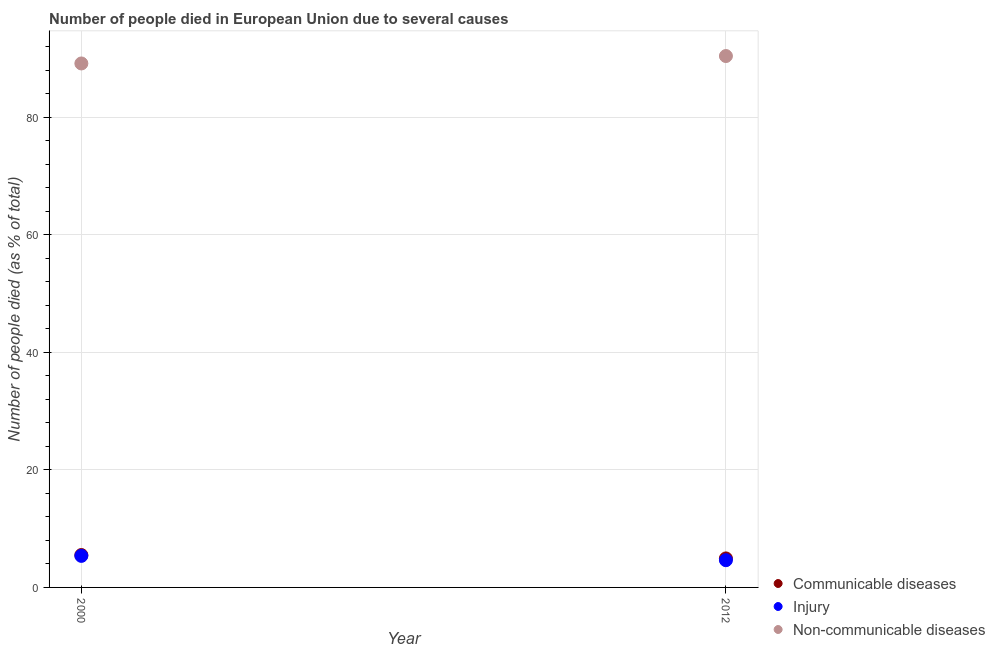How many different coloured dotlines are there?
Your answer should be very brief. 3. Is the number of dotlines equal to the number of legend labels?
Keep it short and to the point. Yes. What is the number of people who died of communicable diseases in 2012?
Your response must be concise. 4.93. Across all years, what is the maximum number of people who died of injury?
Give a very brief answer. 5.37. Across all years, what is the minimum number of people who died of communicable diseases?
Make the answer very short. 4.93. In which year was the number of people who died of injury minimum?
Ensure brevity in your answer.  2012. What is the total number of people who died of communicable diseases in the graph?
Give a very brief answer. 10.44. What is the difference between the number of people who dies of non-communicable diseases in 2000 and that in 2012?
Provide a short and direct response. -1.26. What is the difference between the number of people who dies of non-communicable diseases in 2012 and the number of people who died of communicable diseases in 2000?
Offer a terse response. 84.89. What is the average number of people who dies of non-communicable diseases per year?
Your response must be concise. 89.77. In the year 2000, what is the difference between the number of people who died of injury and number of people who died of communicable diseases?
Make the answer very short. -0.14. In how many years, is the number of people who died of communicable diseases greater than 36 %?
Ensure brevity in your answer.  0. What is the ratio of the number of people who dies of non-communicable diseases in 2000 to that in 2012?
Your response must be concise. 0.99. Is the number of people who died of injury in 2000 less than that in 2012?
Offer a very short reply. No. Is it the case that in every year, the sum of the number of people who died of communicable diseases and number of people who died of injury is greater than the number of people who dies of non-communicable diseases?
Keep it short and to the point. No. Does the number of people who dies of non-communicable diseases monotonically increase over the years?
Make the answer very short. Yes. Is the number of people who dies of non-communicable diseases strictly less than the number of people who died of communicable diseases over the years?
Your answer should be very brief. No. How many dotlines are there?
Ensure brevity in your answer.  3. What is the difference between two consecutive major ticks on the Y-axis?
Your answer should be compact. 20. Does the graph contain grids?
Provide a short and direct response. Yes. What is the title of the graph?
Offer a very short reply. Number of people died in European Union due to several causes. What is the label or title of the X-axis?
Give a very brief answer. Year. What is the label or title of the Y-axis?
Offer a very short reply. Number of people died (as % of total). What is the Number of people died (as % of total) in Communicable diseases in 2000?
Provide a short and direct response. 5.51. What is the Number of people died (as % of total) in Injury in 2000?
Make the answer very short. 5.37. What is the Number of people died (as % of total) of Non-communicable diseases in 2000?
Provide a short and direct response. 89.14. What is the Number of people died (as % of total) in Communicable diseases in 2012?
Give a very brief answer. 4.93. What is the Number of people died (as % of total) in Injury in 2012?
Keep it short and to the point. 4.63. What is the Number of people died (as % of total) of Non-communicable diseases in 2012?
Make the answer very short. 90.4. Across all years, what is the maximum Number of people died (as % of total) in Communicable diseases?
Your response must be concise. 5.51. Across all years, what is the maximum Number of people died (as % of total) in Injury?
Your response must be concise. 5.37. Across all years, what is the maximum Number of people died (as % of total) in Non-communicable diseases?
Your answer should be compact. 90.4. Across all years, what is the minimum Number of people died (as % of total) of Communicable diseases?
Offer a terse response. 4.93. Across all years, what is the minimum Number of people died (as % of total) of Injury?
Offer a very short reply. 4.63. Across all years, what is the minimum Number of people died (as % of total) of Non-communicable diseases?
Provide a succinct answer. 89.14. What is the total Number of people died (as % of total) in Communicable diseases in the graph?
Make the answer very short. 10.44. What is the total Number of people died (as % of total) in Injury in the graph?
Make the answer very short. 10. What is the total Number of people died (as % of total) in Non-communicable diseases in the graph?
Keep it short and to the point. 179.54. What is the difference between the Number of people died (as % of total) of Communicable diseases in 2000 and that in 2012?
Offer a terse response. 0.57. What is the difference between the Number of people died (as % of total) in Injury in 2000 and that in 2012?
Make the answer very short. 0.74. What is the difference between the Number of people died (as % of total) of Non-communicable diseases in 2000 and that in 2012?
Provide a short and direct response. -1.26. What is the difference between the Number of people died (as % of total) of Communicable diseases in 2000 and the Number of people died (as % of total) of Injury in 2012?
Your answer should be compact. 0.88. What is the difference between the Number of people died (as % of total) of Communicable diseases in 2000 and the Number of people died (as % of total) of Non-communicable diseases in 2012?
Your response must be concise. -84.89. What is the difference between the Number of people died (as % of total) of Injury in 2000 and the Number of people died (as % of total) of Non-communicable diseases in 2012?
Make the answer very short. -85.03. What is the average Number of people died (as % of total) in Communicable diseases per year?
Ensure brevity in your answer.  5.22. What is the average Number of people died (as % of total) of Injury per year?
Keep it short and to the point. 5. What is the average Number of people died (as % of total) in Non-communicable diseases per year?
Make the answer very short. 89.77. In the year 2000, what is the difference between the Number of people died (as % of total) in Communicable diseases and Number of people died (as % of total) in Injury?
Provide a short and direct response. 0.14. In the year 2000, what is the difference between the Number of people died (as % of total) in Communicable diseases and Number of people died (as % of total) in Non-communicable diseases?
Keep it short and to the point. -83.63. In the year 2000, what is the difference between the Number of people died (as % of total) of Injury and Number of people died (as % of total) of Non-communicable diseases?
Your response must be concise. -83.77. In the year 2012, what is the difference between the Number of people died (as % of total) of Communicable diseases and Number of people died (as % of total) of Injury?
Make the answer very short. 0.3. In the year 2012, what is the difference between the Number of people died (as % of total) of Communicable diseases and Number of people died (as % of total) of Non-communicable diseases?
Offer a very short reply. -85.47. In the year 2012, what is the difference between the Number of people died (as % of total) of Injury and Number of people died (as % of total) of Non-communicable diseases?
Provide a short and direct response. -85.77. What is the ratio of the Number of people died (as % of total) in Communicable diseases in 2000 to that in 2012?
Offer a very short reply. 1.12. What is the ratio of the Number of people died (as % of total) of Injury in 2000 to that in 2012?
Your response must be concise. 1.16. What is the ratio of the Number of people died (as % of total) of Non-communicable diseases in 2000 to that in 2012?
Give a very brief answer. 0.99. What is the difference between the highest and the second highest Number of people died (as % of total) of Communicable diseases?
Your response must be concise. 0.57. What is the difference between the highest and the second highest Number of people died (as % of total) in Injury?
Ensure brevity in your answer.  0.74. What is the difference between the highest and the second highest Number of people died (as % of total) of Non-communicable diseases?
Offer a terse response. 1.26. What is the difference between the highest and the lowest Number of people died (as % of total) in Communicable diseases?
Your answer should be compact. 0.57. What is the difference between the highest and the lowest Number of people died (as % of total) in Injury?
Provide a short and direct response. 0.74. What is the difference between the highest and the lowest Number of people died (as % of total) of Non-communicable diseases?
Offer a very short reply. 1.26. 